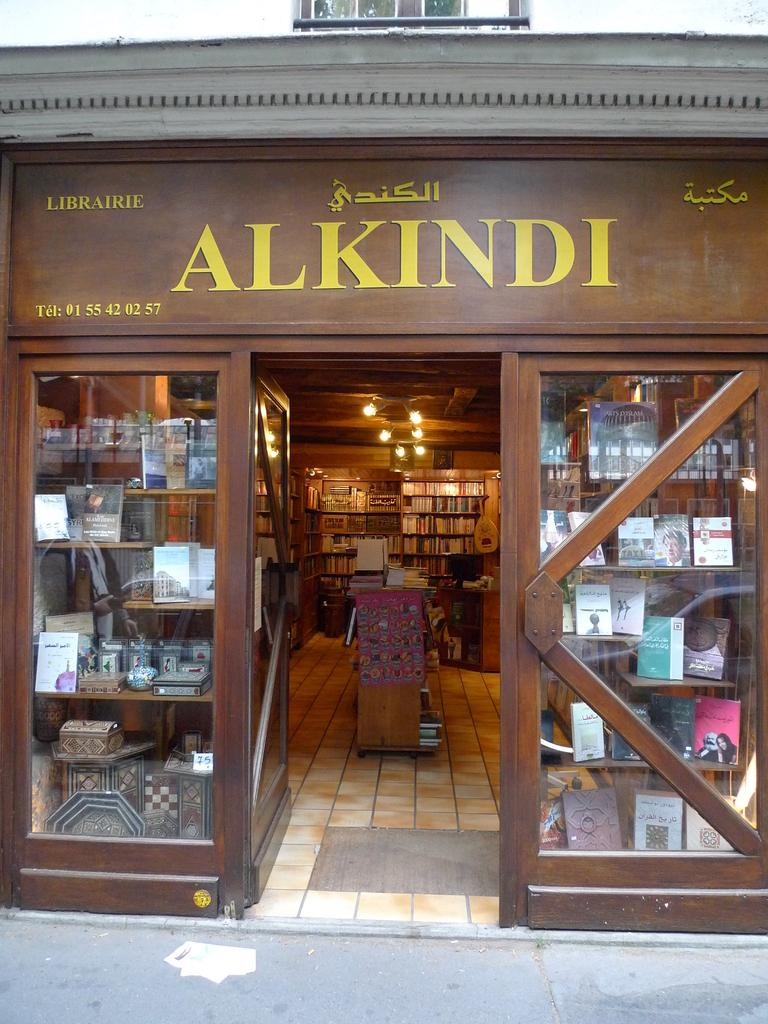<image>
Summarize the visual content of the image. Store front of Alkindi that shows many of it's products. 